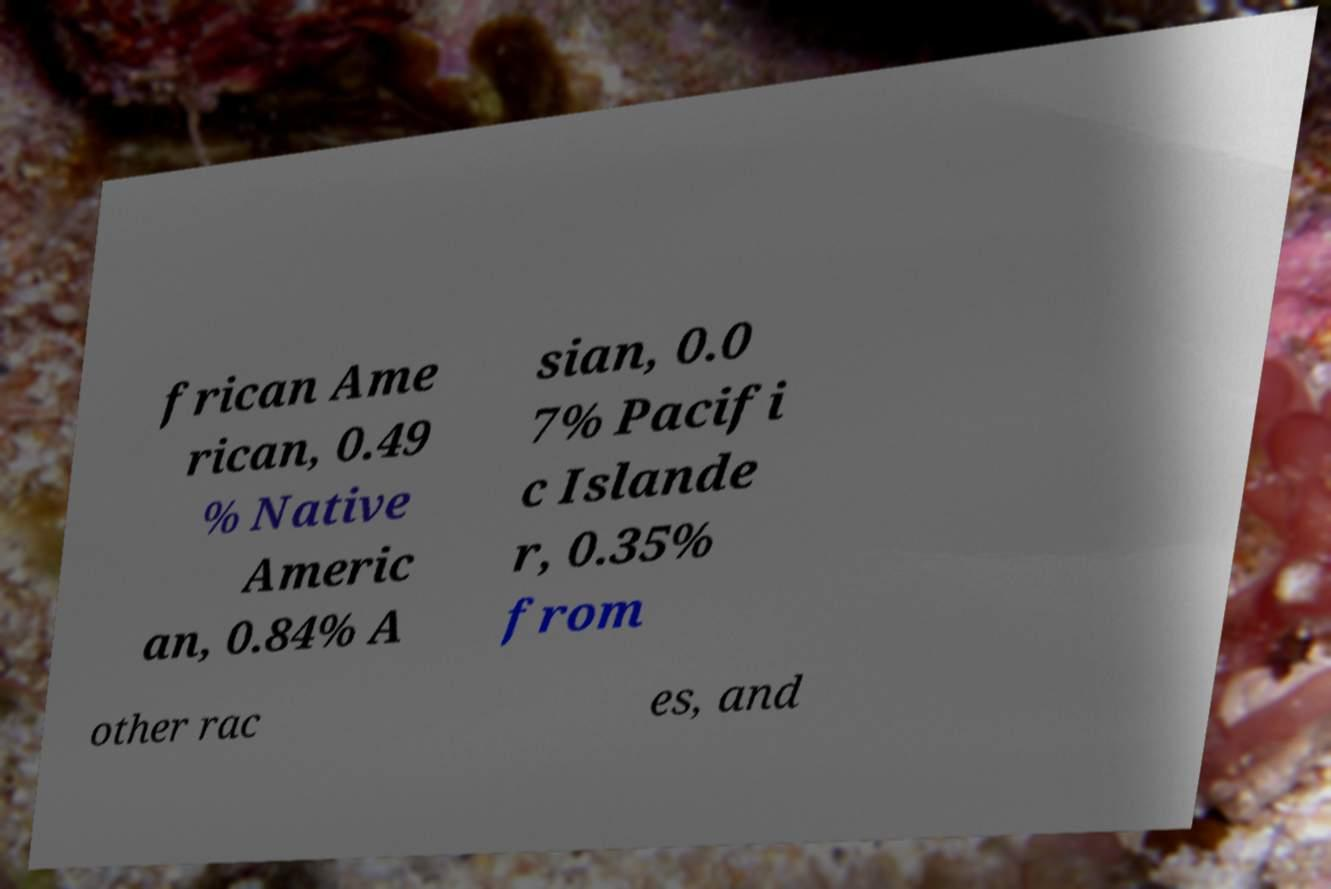Can you read and provide the text displayed in the image?This photo seems to have some interesting text. Can you extract and type it out for me? frican Ame rican, 0.49 % Native Americ an, 0.84% A sian, 0.0 7% Pacifi c Islande r, 0.35% from other rac es, and 